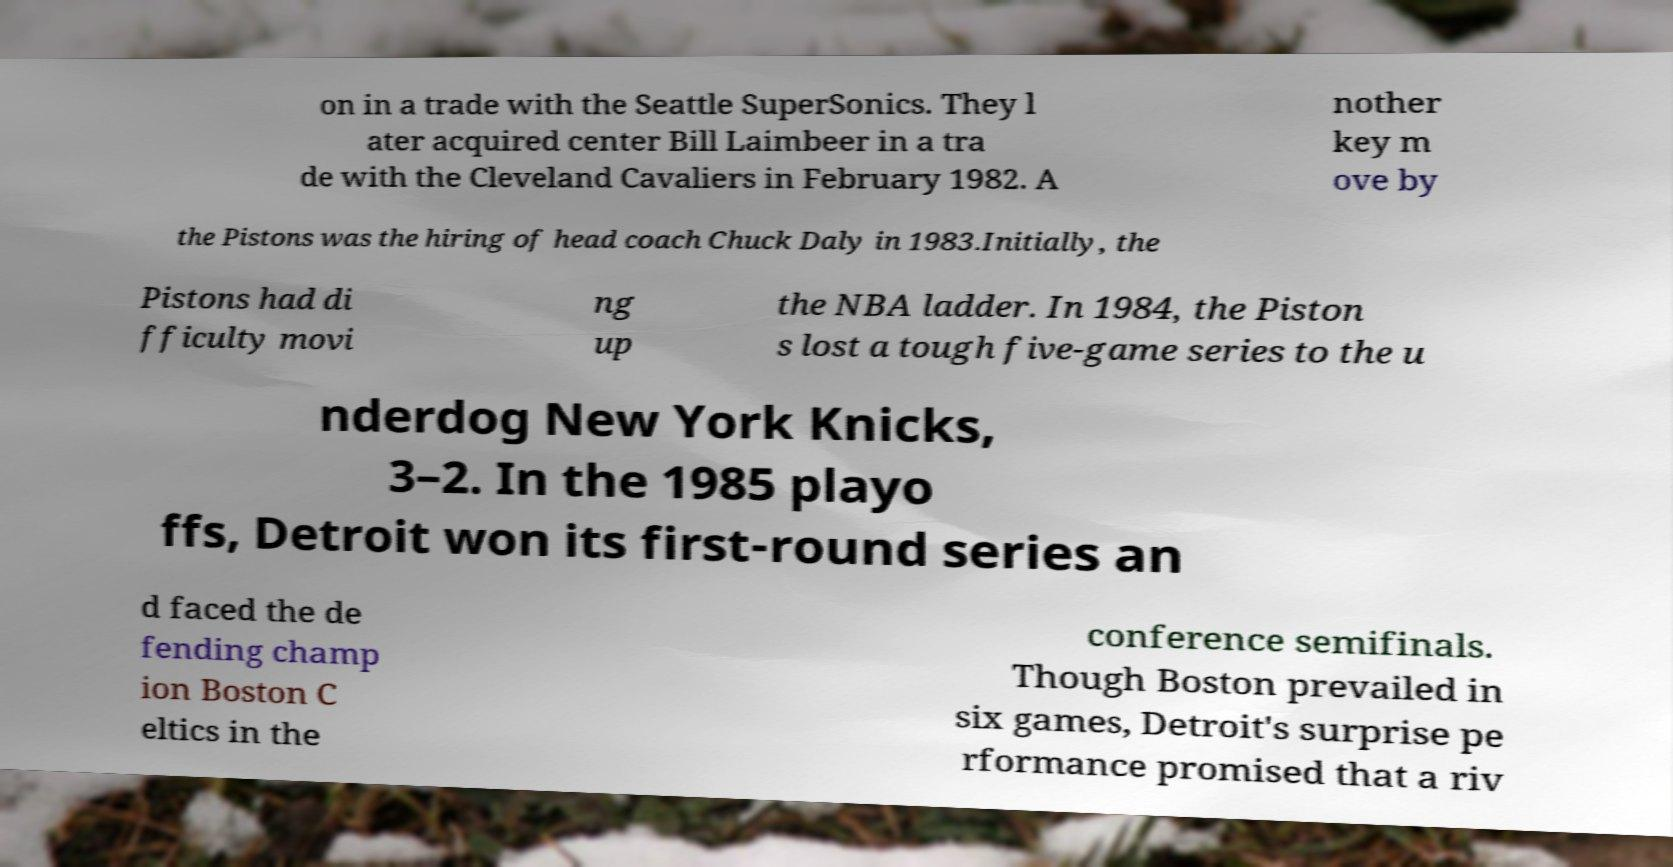I need the written content from this picture converted into text. Can you do that? on in a trade with the Seattle SuperSonics. They l ater acquired center Bill Laimbeer in a tra de with the Cleveland Cavaliers in February 1982. A nother key m ove by the Pistons was the hiring of head coach Chuck Daly in 1983.Initially, the Pistons had di fficulty movi ng up the NBA ladder. In 1984, the Piston s lost a tough five-game series to the u nderdog New York Knicks, 3–2. In the 1985 playo ffs, Detroit won its first-round series an d faced the de fending champ ion Boston C eltics in the conference semifinals. Though Boston prevailed in six games, Detroit's surprise pe rformance promised that a riv 